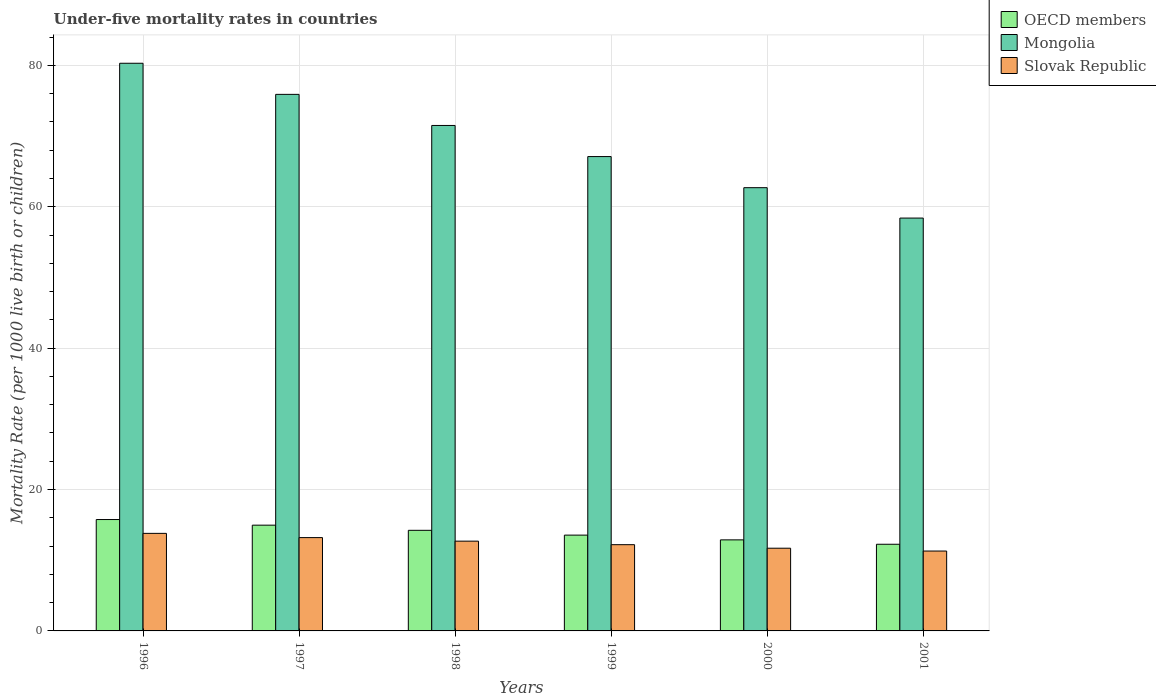How many different coloured bars are there?
Make the answer very short. 3. How many groups of bars are there?
Ensure brevity in your answer.  6. Are the number of bars on each tick of the X-axis equal?
Ensure brevity in your answer.  Yes. What is the label of the 4th group of bars from the left?
Ensure brevity in your answer.  1999. In how many cases, is the number of bars for a given year not equal to the number of legend labels?
Make the answer very short. 0. What is the under-five mortality rate in Mongolia in 1998?
Give a very brief answer. 71.5. Across all years, what is the maximum under-five mortality rate in OECD members?
Keep it short and to the point. 15.76. Across all years, what is the minimum under-five mortality rate in Mongolia?
Your answer should be very brief. 58.4. In which year was the under-five mortality rate in Mongolia maximum?
Your answer should be compact. 1996. What is the total under-five mortality rate in Slovak Republic in the graph?
Offer a terse response. 74.9. What is the difference between the under-five mortality rate in Mongolia in 1996 and that in 1998?
Your answer should be very brief. 8.8. What is the difference between the under-five mortality rate in Mongolia in 1999 and the under-five mortality rate in OECD members in 1996?
Your answer should be compact. 51.34. What is the average under-five mortality rate in Mongolia per year?
Your response must be concise. 69.32. In the year 1997, what is the difference between the under-five mortality rate in OECD members and under-five mortality rate in Mongolia?
Provide a succinct answer. -60.94. What is the ratio of the under-five mortality rate in OECD members in 1997 to that in 1998?
Give a very brief answer. 1.05. Is the under-five mortality rate in OECD members in 1997 less than that in 2000?
Your response must be concise. No. What is the difference between the highest and the second highest under-five mortality rate in Mongolia?
Give a very brief answer. 4.4. What is the difference between the highest and the lowest under-five mortality rate in Slovak Republic?
Offer a very short reply. 2.5. What does the 1st bar from the left in 2001 represents?
Make the answer very short. OECD members. What does the 1st bar from the right in 1998 represents?
Ensure brevity in your answer.  Slovak Republic. How many bars are there?
Offer a terse response. 18. How many years are there in the graph?
Make the answer very short. 6. Does the graph contain any zero values?
Ensure brevity in your answer.  No. How are the legend labels stacked?
Ensure brevity in your answer.  Vertical. What is the title of the graph?
Your answer should be very brief. Under-five mortality rates in countries. What is the label or title of the X-axis?
Offer a very short reply. Years. What is the label or title of the Y-axis?
Make the answer very short. Mortality Rate (per 1000 live birth or children). What is the Mortality Rate (per 1000 live birth or children) of OECD members in 1996?
Your answer should be very brief. 15.76. What is the Mortality Rate (per 1000 live birth or children) in Mongolia in 1996?
Provide a short and direct response. 80.3. What is the Mortality Rate (per 1000 live birth or children) of Slovak Republic in 1996?
Offer a very short reply. 13.8. What is the Mortality Rate (per 1000 live birth or children) in OECD members in 1997?
Offer a very short reply. 14.96. What is the Mortality Rate (per 1000 live birth or children) in Mongolia in 1997?
Offer a very short reply. 75.9. What is the Mortality Rate (per 1000 live birth or children) of OECD members in 1998?
Offer a terse response. 14.23. What is the Mortality Rate (per 1000 live birth or children) in Mongolia in 1998?
Provide a short and direct response. 71.5. What is the Mortality Rate (per 1000 live birth or children) of Slovak Republic in 1998?
Keep it short and to the point. 12.7. What is the Mortality Rate (per 1000 live birth or children) of OECD members in 1999?
Give a very brief answer. 13.55. What is the Mortality Rate (per 1000 live birth or children) in Mongolia in 1999?
Provide a short and direct response. 67.1. What is the Mortality Rate (per 1000 live birth or children) of Slovak Republic in 1999?
Provide a succinct answer. 12.2. What is the Mortality Rate (per 1000 live birth or children) in OECD members in 2000?
Offer a very short reply. 12.88. What is the Mortality Rate (per 1000 live birth or children) of Mongolia in 2000?
Your response must be concise. 62.7. What is the Mortality Rate (per 1000 live birth or children) in OECD members in 2001?
Provide a short and direct response. 12.26. What is the Mortality Rate (per 1000 live birth or children) in Mongolia in 2001?
Provide a short and direct response. 58.4. What is the Mortality Rate (per 1000 live birth or children) of Slovak Republic in 2001?
Offer a terse response. 11.3. Across all years, what is the maximum Mortality Rate (per 1000 live birth or children) in OECD members?
Your response must be concise. 15.76. Across all years, what is the maximum Mortality Rate (per 1000 live birth or children) of Mongolia?
Your answer should be very brief. 80.3. Across all years, what is the maximum Mortality Rate (per 1000 live birth or children) in Slovak Republic?
Your answer should be compact. 13.8. Across all years, what is the minimum Mortality Rate (per 1000 live birth or children) in OECD members?
Provide a succinct answer. 12.26. Across all years, what is the minimum Mortality Rate (per 1000 live birth or children) in Mongolia?
Offer a terse response. 58.4. What is the total Mortality Rate (per 1000 live birth or children) in OECD members in the graph?
Make the answer very short. 83.64. What is the total Mortality Rate (per 1000 live birth or children) of Mongolia in the graph?
Provide a short and direct response. 415.9. What is the total Mortality Rate (per 1000 live birth or children) of Slovak Republic in the graph?
Keep it short and to the point. 74.9. What is the difference between the Mortality Rate (per 1000 live birth or children) in OECD members in 1996 and that in 1997?
Ensure brevity in your answer.  0.8. What is the difference between the Mortality Rate (per 1000 live birth or children) in OECD members in 1996 and that in 1998?
Offer a terse response. 1.53. What is the difference between the Mortality Rate (per 1000 live birth or children) in OECD members in 1996 and that in 1999?
Offer a very short reply. 2.2. What is the difference between the Mortality Rate (per 1000 live birth or children) in OECD members in 1996 and that in 2000?
Give a very brief answer. 2.88. What is the difference between the Mortality Rate (per 1000 live birth or children) of Slovak Republic in 1996 and that in 2000?
Ensure brevity in your answer.  2.1. What is the difference between the Mortality Rate (per 1000 live birth or children) in OECD members in 1996 and that in 2001?
Your answer should be compact. 3.5. What is the difference between the Mortality Rate (per 1000 live birth or children) in Mongolia in 1996 and that in 2001?
Make the answer very short. 21.9. What is the difference between the Mortality Rate (per 1000 live birth or children) of OECD members in 1997 and that in 1998?
Make the answer very short. 0.73. What is the difference between the Mortality Rate (per 1000 live birth or children) in Mongolia in 1997 and that in 1998?
Give a very brief answer. 4.4. What is the difference between the Mortality Rate (per 1000 live birth or children) in Slovak Republic in 1997 and that in 1998?
Offer a very short reply. 0.5. What is the difference between the Mortality Rate (per 1000 live birth or children) of OECD members in 1997 and that in 1999?
Give a very brief answer. 1.41. What is the difference between the Mortality Rate (per 1000 live birth or children) in Mongolia in 1997 and that in 1999?
Offer a very short reply. 8.8. What is the difference between the Mortality Rate (per 1000 live birth or children) in OECD members in 1997 and that in 2000?
Make the answer very short. 2.08. What is the difference between the Mortality Rate (per 1000 live birth or children) in OECD members in 1997 and that in 2001?
Keep it short and to the point. 2.7. What is the difference between the Mortality Rate (per 1000 live birth or children) of Mongolia in 1997 and that in 2001?
Offer a terse response. 17.5. What is the difference between the Mortality Rate (per 1000 live birth or children) in Slovak Republic in 1997 and that in 2001?
Your answer should be compact. 1.9. What is the difference between the Mortality Rate (per 1000 live birth or children) in OECD members in 1998 and that in 1999?
Ensure brevity in your answer.  0.68. What is the difference between the Mortality Rate (per 1000 live birth or children) of Slovak Republic in 1998 and that in 1999?
Make the answer very short. 0.5. What is the difference between the Mortality Rate (per 1000 live birth or children) in OECD members in 1998 and that in 2000?
Offer a very short reply. 1.35. What is the difference between the Mortality Rate (per 1000 live birth or children) of OECD members in 1998 and that in 2001?
Provide a short and direct response. 1.97. What is the difference between the Mortality Rate (per 1000 live birth or children) in Mongolia in 1998 and that in 2001?
Provide a short and direct response. 13.1. What is the difference between the Mortality Rate (per 1000 live birth or children) of OECD members in 1999 and that in 2000?
Give a very brief answer. 0.67. What is the difference between the Mortality Rate (per 1000 live birth or children) of Mongolia in 1999 and that in 2000?
Your answer should be compact. 4.4. What is the difference between the Mortality Rate (per 1000 live birth or children) of Slovak Republic in 1999 and that in 2000?
Make the answer very short. 0.5. What is the difference between the Mortality Rate (per 1000 live birth or children) of OECD members in 1999 and that in 2001?
Your answer should be compact. 1.29. What is the difference between the Mortality Rate (per 1000 live birth or children) of Mongolia in 1999 and that in 2001?
Offer a very short reply. 8.7. What is the difference between the Mortality Rate (per 1000 live birth or children) of Slovak Republic in 1999 and that in 2001?
Give a very brief answer. 0.9. What is the difference between the Mortality Rate (per 1000 live birth or children) of OECD members in 2000 and that in 2001?
Offer a terse response. 0.62. What is the difference between the Mortality Rate (per 1000 live birth or children) of Mongolia in 2000 and that in 2001?
Give a very brief answer. 4.3. What is the difference between the Mortality Rate (per 1000 live birth or children) of Slovak Republic in 2000 and that in 2001?
Provide a short and direct response. 0.4. What is the difference between the Mortality Rate (per 1000 live birth or children) in OECD members in 1996 and the Mortality Rate (per 1000 live birth or children) in Mongolia in 1997?
Your answer should be very brief. -60.14. What is the difference between the Mortality Rate (per 1000 live birth or children) of OECD members in 1996 and the Mortality Rate (per 1000 live birth or children) of Slovak Republic in 1997?
Give a very brief answer. 2.56. What is the difference between the Mortality Rate (per 1000 live birth or children) of Mongolia in 1996 and the Mortality Rate (per 1000 live birth or children) of Slovak Republic in 1997?
Make the answer very short. 67.1. What is the difference between the Mortality Rate (per 1000 live birth or children) in OECD members in 1996 and the Mortality Rate (per 1000 live birth or children) in Mongolia in 1998?
Make the answer very short. -55.74. What is the difference between the Mortality Rate (per 1000 live birth or children) of OECD members in 1996 and the Mortality Rate (per 1000 live birth or children) of Slovak Republic in 1998?
Your answer should be very brief. 3.06. What is the difference between the Mortality Rate (per 1000 live birth or children) of Mongolia in 1996 and the Mortality Rate (per 1000 live birth or children) of Slovak Republic in 1998?
Provide a succinct answer. 67.6. What is the difference between the Mortality Rate (per 1000 live birth or children) in OECD members in 1996 and the Mortality Rate (per 1000 live birth or children) in Mongolia in 1999?
Make the answer very short. -51.34. What is the difference between the Mortality Rate (per 1000 live birth or children) in OECD members in 1996 and the Mortality Rate (per 1000 live birth or children) in Slovak Republic in 1999?
Offer a very short reply. 3.56. What is the difference between the Mortality Rate (per 1000 live birth or children) in Mongolia in 1996 and the Mortality Rate (per 1000 live birth or children) in Slovak Republic in 1999?
Your answer should be compact. 68.1. What is the difference between the Mortality Rate (per 1000 live birth or children) of OECD members in 1996 and the Mortality Rate (per 1000 live birth or children) of Mongolia in 2000?
Your answer should be compact. -46.94. What is the difference between the Mortality Rate (per 1000 live birth or children) of OECD members in 1996 and the Mortality Rate (per 1000 live birth or children) of Slovak Republic in 2000?
Your response must be concise. 4.06. What is the difference between the Mortality Rate (per 1000 live birth or children) of Mongolia in 1996 and the Mortality Rate (per 1000 live birth or children) of Slovak Republic in 2000?
Your answer should be very brief. 68.6. What is the difference between the Mortality Rate (per 1000 live birth or children) in OECD members in 1996 and the Mortality Rate (per 1000 live birth or children) in Mongolia in 2001?
Make the answer very short. -42.64. What is the difference between the Mortality Rate (per 1000 live birth or children) in OECD members in 1996 and the Mortality Rate (per 1000 live birth or children) in Slovak Republic in 2001?
Your answer should be very brief. 4.46. What is the difference between the Mortality Rate (per 1000 live birth or children) of OECD members in 1997 and the Mortality Rate (per 1000 live birth or children) of Mongolia in 1998?
Make the answer very short. -56.54. What is the difference between the Mortality Rate (per 1000 live birth or children) of OECD members in 1997 and the Mortality Rate (per 1000 live birth or children) of Slovak Republic in 1998?
Keep it short and to the point. 2.26. What is the difference between the Mortality Rate (per 1000 live birth or children) in Mongolia in 1997 and the Mortality Rate (per 1000 live birth or children) in Slovak Republic in 1998?
Offer a terse response. 63.2. What is the difference between the Mortality Rate (per 1000 live birth or children) of OECD members in 1997 and the Mortality Rate (per 1000 live birth or children) of Mongolia in 1999?
Provide a short and direct response. -52.14. What is the difference between the Mortality Rate (per 1000 live birth or children) in OECD members in 1997 and the Mortality Rate (per 1000 live birth or children) in Slovak Republic in 1999?
Ensure brevity in your answer.  2.76. What is the difference between the Mortality Rate (per 1000 live birth or children) in Mongolia in 1997 and the Mortality Rate (per 1000 live birth or children) in Slovak Republic in 1999?
Make the answer very short. 63.7. What is the difference between the Mortality Rate (per 1000 live birth or children) of OECD members in 1997 and the Mortality Rate (per 1000 live birth or children) of Mongolia in 2000?
Make the answer very short. -47.74. What is the difference between the Mortality Rate (per 1000 live birth or children) of OECD members in 1997 and the Mortality Rate (per 1000 live birth or children) of Slovak Republic in 2000?
Your response must be concise. 3.26. What is the difference between the Mortality Rate (per 1000 live birth or children) of Mongolia in 1997 and the Mortality Rate (per 1000 live birth or children) of Slovak Republic in 2000?
Your response must be concise. 64.2. What is the difference between the Mortality Rate (per 1000 live birth or children) of OECD members in 1997 and the Mortality Rate (per 1000 live birth or children) of Mongolia in 2001?
Provide a succinct answer. -43.44. What is the difference between the Mortality Rate (per 1000 live birth or children) in OECD members in 1997 and the Mortality Rate (per 1000 live birth or children) in Slovak Republic in 2001?
Give a very brief answer. 3.66. What is the difference between the Mortality Rate (per 1000 live birth or children) of Mongolia in 1997 and the Mortality Rate (per 1000 live birth or children) of Slovak Republic in 2001?
Your answer should be very brief. 64.6. What is the difference between the Mortality Rate (per 1000 live birth or children) in OECD members in 1998 and the Mortality Rate (per 1000 live birth or children) in Mongolia in 1999?
Make the answer very short. -52.87. What is the difference between the Mortality Rate (per 1000 live birth or children) in OECD members in 1998 and the Mortality Rate (per 1000 live birth or children) in Slovak Republic in 1999?
Ensure brevity in your answer.  2.03. What is the difference between the Mortality Rate (per 1000 live birth or children) in Mongolia in 1998 and the Mortality Rate (per 1000 live birth or children) in Slovak Republic in 1999?
Provide a short and direct response. 59.3. What is the difference between the Mortality Rate (per 1000 live birth or children) in OECD members in 1998 and the Mortality Rate (per 1000 live birth or children) in Mongolia in 2000?
Offer a terse response. -48.47. What is the difference between the Mortality Rate (per 1000 live birth or children) in OECD members in 1998 and the Mortality Rate (per 1000 live birth or children) in Slovak Republic in 2000?
Make the answer very short. 2.53. What is the difference between the Mortality Rate (per 1000 live birth or children) of Mongolia in 1998 and the Mortality Rate (per 1000 live birth or children) of Slovak Republic in 2000?
Your answer should be very brief. 59.8. What is the difference between the Mortality Rate (per 1000 live birth or children) of OECD members in 1998 and the Mortality Rate (per 1000 live birth or children) of Mongolia in 2001?
Ensure brevity in your answer.  -44.17. What is the difference between the Mortality Rate (per 1000 live birth or children) of OECD members in 1998 and the Mortality Rate (per 1000 live birth or children) of Slovak Republic in 2001?
Offer a very short reply. 2.93. What is the difference between the Mortality Rate (per 1000 live birth or children) in Mongolia in 1998 and the Mortality Rate (per 1000 live birth or children) in Slovak Republic in 2001?
Give a very brief answer. 60.2. What is the difference between the Mortality Rate (per 1000 live birth or children) of OECD members in 1999 and the Mortality Rate (per 1000 live birth or children) of Mongolia in 2000?
Provide a short and direct response. -49.15. What is the difference between the Mortality Rate (per 1000 live birth or children) of OECD members in 1999 and the Mortality Rate (per 1000 live birth or children) of Slovak Republic in 2000?
Ensure brevity in your answer.  1.85. What is the difference between the Mortality Rate (per 1000 live birth or children) in Mongolia in 1999 and the Mortality Rate (per 1000 live birth or children) in Slovak Republic in 2000?
Keep it short and to the point. 55.4. What is the difference between the Mortality Rate (per 1000 live birth or children) in OECD members in 1999 and the Mortality Rate (per 1000 live birth or children) in Mongolia in 2001?
Your answer should be compact. -44.85. What is the difference between the Mortality Rate (per 1000 live birth or children) of OECD members in 1999 and the Mortality Rate (per 1000 live birth or children) of Slovak Republic in 2001?
Your response must be concise. 2.25. What is the difference between the Mortality Rate (per 1000 live birth or children) in Mongolia in 1999 and the Mortality Rate (per 1000 live birth or children) in Slovak Republic in 2001?
Give a very brief answer. 55.8. What is the difference between the Mortality Rate (per 1000 live birth or children) of OECD members in 2000 and the Mortality Rate (per 1000 live birth or children) of Mongolia in 2001?
Give a very brief answer. -45.52. What is the difference between the Mortality Rate (per 1000 live birth or children) in OECD members in 2000 and the Mortality Rate (per 1000 live birth or children) in Slovak Republic in 2001?
Offer a very short reply. 1.58. What is the difference between the Mortality Rate (per 1000 live birth or children) in Mongolia in 2000 and the Mortality Rate (per 1000 live birth or children) in Slovak Republic in 2001?
Your answer should be compact. 51.4. What is the average Mortality Rate (per 1000 live birth or children) in OECD members per year?
Keep it short and to the point. 13.94. What is the average Mortality Rate (per 1000 live birth or children) in Mongolia per year?
Offer a very short reply. 69.32. What is the average Mortality Rate (per 1000 live birth or children) of Slovak Republic per year?
Ensure brevity in your answer.  12.48. In the year 1996, what is the difference between the Mortality Rate (per 1000 live birth or children) of OECD members and Mortality Rate (per 1000 live birth or children) of Mongolia?
Your response must be concise. -64.54. In the year 1996, what is the difference between the Mortality Rate (per 1000 live birth or children) in OECD members and Mortality Rate (per 1000 live birth or children) in Slovak Republic?
Offer a terse response. 1.96. In the year 1996, what is the difference between the Mortality Rate (per 1000 live birth or children) in Mongolia and Mortality Rate (per 1000 live birth or children) in Slovak Republic?
Your answer should be very brief. 66.5. In the year 1997, what is the difference between the Mortality Rate (per 1000 live birth or children) of OECD members and Mortality Rate (per 1000 live birth or children) of Mongolia?
Your answer should be very brief. -60.94. In the year 1997, what is the difference between the Mortality Rate (per 1000 live birth or children) in OECD members and Mortality Rate (per 1000 live birth or children) in Slovak Republic?
Ensure brevity in your answer.  1.76. In the year 1997, what is the difference between the Mortality Rate (per 1000 live birth or children) of Mongolia and Mortality Rate (per 1000 live birth or children) of Slovak Republic?
Keep it short and to the point. 62.7. In the year 1998, what is the difference between the Mortality Rate (per 1000 live birth or children) of OECD members and Mortality Rate (per 1000 live birth or children) of Mongolia?
Offer a terse response. -57.27. In the year 1998, what is the difference between the Mortality Rate (per 1000 live birth or children) of OECD members and Mortality Rate (per 1000 live birth or children) of Slovak Republic?
Ensure brevity in your answer.  1.53. In the year 1998, what is the difference between the Mortality Rate (per 1000 live birth or children) in Mongolia and Mortality Rate (per 1000 live birth or children) in Slovak Republic?
Keep it short and to the point. 58.8. In the year 1999, what is the difference between the Mortality Rate (per 1000 live birth or children) of OECD members and Mortality Rate (per 1000 live birth or children) of Mongolia?
Your answer should be compact. -53.55. In the year 1999, what is the difference between the Mortality Rate (per 1000 live birth or children) of OECD members and Mortality Rate (per 1000 live birth or children) of Slovak Republic?
Give a very brief answer. 1.35. In the year 1999, what is the difference between the Mortality Rate (per 1000 live birth or children) of Mongolia and Mortality Rate (per 1000 live birth or children) of Slovak Republic?
Your answer should be compact. 54.9. In the year 2000, what is the difference between the Mortality Rate (per 1000 live birth or children) of OECD members and Mortality Rate (per 1000 live birth or children) of Mongolia?
Offer a very short reply. -49.82. In the year 2000, what is the difference between the Mortality Rate (per 1000 live birth or children) of OECD members and Mortality Rate (per 1000 live birth or children) of Slovak Republic?
Give a very brief answer. 1.18. In the year 2000, what is the difference between the Mortality Rate (per 1000 live birth or children) in Mongolia and Mortality Rate (per 1000 live birth or children) in Slovak Republic?
Keep it short and to the point. 51. In the year 2001, what is the difference between the Mortality Rate (per 1000 live birth or children) in OECD members and Mortality Rate (per 1000 live birth or children) in Mongolia?
Your answer should be very brief. -46.14. In the year 2001, what is the difference between the Mortality Rate (per 1000 live birth or children) of OECD members and Mortality Rate (per 1000 live birth or children) of Slovak Republic?
Ensure brevity in your answer.  0.96. In the year 2001, what is the difference between the Mortality Rate (per 1000 live birth or children) in Mongolia and Mortality Rate (per 1000 live birth or children) in Slovak Republic?
Your response must be concise. 47.1. What is the ratio of the Mortality Rate (per 1000 live birth or children) of OECD members in 1996 to that in 1997?
Offer a very short reply. 1.05. What is the ratio of the Mortality Rate (per 1000 live birth or children) of Mongolia in 1996 to that in 1997?
Your response must be concise. 1.06. What is the ratio of the Mortality Rate (per 1000 live birth or children) of Slovak Republic in 1996 to that in 1997?
Offer a very short reply. 1.05. What is the ratio of the Mortality Rate (per 1000 live birth or children) in OECD members in 1996 to that in 1998?
Your answer should be compact. 1.11. What is the ratio of the Mortality Rate (per 1000 live birth or children) in Mongolia in 1996 to that in 1998?
Offer a very short reply. 1.12. What is the ratio of the Mortality Rate (per 1000 live birth or children) of Slovak Republic in 1996 to that in 1998?
Offer a terse response. 1.09. What is the ratio of the Mortality Rate (per 1000 live birth or children) in OECD members in 1996 to that in 1999?
Provide a short and direct response. 1.16. What is the ratio of the Mortality Rate (per 1000 live birth or children) in Mongolia in 1996 to that in 1999?
Provide a short and direct response. 1.2. What is the ratio of the Mortality Rate (per 1000 live birth or children) of Slovak Republic in 1996 to that in 1999?
Your answer should be compact. 1.13. What is the ratio of the Mortality Rate (per 1000 live birth or children) of OECD members in 1996 to that in 2000?
Ensure brevity in your answer.  1.22. What is the ratio of the Mortality Rate (per 1000 live birth or children) in Mongolia in 1996 to that in 2000?
Your answer should be very brief. 1.28. What is the ratio of the Mortality Rate (per 1000 live birth or children) of Slovak Republic in 1996 to that in 2000?
Make the answer very short. 1.18. What is the ratio of the Mortality Rate (per 1000 live birth or children) of OECD members in 1996 to that in 2001?
Your answer should be very brief. 1.29. What is the ratio of the Mortality Rate (per 1000 live birth or children) in Mongolia in 1996 to that in 2001?
Ensure brevity in your answer.  1.38. What is the ratio of the Mortality Rate (per 1000 live birth or children) of Slovak Republic in 1996 to that in 2001?
Offer a terse response. 1.22. What is the ratio of the Mortality Rate (per 1000 live birth or children) of OECD members in 1997 to that in 1998?
Make the answer very short. 1.05. What is the ratio of the Mortality Rate (per 1000 live birth or children) of Mongolia in 1997 to that in 1998?
Make the answer very short. 1.06. What is the ratio of the Mortality Rate (per 1000 live birth or children) in Slovak Republic in 1997 to that in 1998?
Ensure brevity in your answer.  1.04. What is the ratio of the Mortality Rate (per 1000 live birth or children) in OECD members in 1997 to that in 1999?
Offer a very short reply. 1.1. What is the ratio of the Mortality Rate (per 1000 live birth or children) in Mongolia in 1997 to that in 1999?
Provide a succinct answer. 1.13. What is the ratio of the Mortality Rate (per 1000 live birth or children) in Slovak Republic in 1997 to that in 1999?
Your answer should be compact. 1.08. What is the ratio of the Mortality Rate (per 1000 live birth or children) of OECD members in 1997 to that in 2000?
Offer a very short reply. 1.16. What is the ratio of the Mortality Rate (per 1000 live birth or children) in Mongolia in 1997 to that in 2000?
Provide a succinct answer. 1.21. What is the ratio of the Mortality Rate (per 1000 live birth or children) of Slovak Republic in 1997 to that in 2000?
Offer a very short reply. 1.13. What is the ratio of the Mortality Rate (per 1000 live birth or children) in OECD members in 1997 to that in 2001?
Provide a succinct answer. 1.22. What is the ratio of the Mortality Rate (per 1000 live birth or children) in Mongolia in 1997 to that in 2001?
Provide a succinct answer. 1.3. What is the ratio of the Mortality Rate (per 1000 live birth or children) in Slovak Republic in 1997 to that in 2001?
Keep it short and to the point. 1.17. What is the ratio of the Mortality Rate (per 1000 live birth or children) in OECD members in 1998 to that in 1999?
Offer a very short reply. 1.05. What is the ratio of the Mortality Rate (per 1000 live birth or children) in Mongolia in 1998 to that in 1999?
Keep it short and to the point. 1.07. What is the ratio of the Mortality Rate (per 1000 live birth or children) of Slovak Republic in 1998 to that in 1999?
Ensure brevity in your answer.  1.04. What is the ratio of the Mortality Rate (per 1000 live birth or children) in OECD members in 1998 to that in 2000?
Your response must be concise. 1.1. What is the ratio of the Mortality Rate (per 1000 live birth or children) in Mongolia in 1998 to that in 2000?
Ensure brevity in your answer.  1.14. What is the ratio of the Mortality Rate (per 1000 live birth or children) in Slovak Republic in 1998 to that in 2000?
Provide a succinct answer. 1.09. What is the ratio of the Mortality Rate (per 1000 live birth or children) in OECD members in 1998 to that in 2001?
Give a very brief answer. 1.16. What is the ratio of the Mortality Rate (per 1000 live birth or children) in Mongolia in 1998 to that in 2001?
Ensure brevity in your answer.  1.22. What is the ratio of the Mortality Rate (per 1000 live birth or children) of Slovak Republic in 1998 to that in 2001?
Your answer should be compact. 1.12. What is the ratio of the Mortality Rate (per 1000 live birth or children) of OECD members in 1999 to that in 2000?
Your answer should be compact. 1.05. What is the ratio of the Mortality Rate (per 1000 live birth or children) in Mongolia in 1999 to that in 2000?
Offer a terse response. 1.07. What is the ratio of the Mortality Rate (per 1000 live birth or children) in Slovak Republic in 1999 to that in 2000?
Ensure brevity in your answer.  1.04. What is the ratio of the Mortality Rate (per 1000 live birth or children) of OECD members in 1999 to that in 2001?
Your answer should be compact. 1.11. What is the ratio of the Mortality Rate (per 1000 live birth or children) in Mongolia in 1999 to that in 2001?
Make the answer very short. 1.15. What is the ratio of the Mortality Rate (per 1000 live birth or children) of Slovak Republic in 1999 to that in 2001?
Offer a terse response. 1.08. What is the ratio of the Mortality Rate (per 1000 live birth or children) in OECD members in 2000 to that in 2001?
Offer a terse response. 1.05. What is the ratio of the Mortality Rate (per 1000 live birth or children) in Mongolia in 2000 to that in 2001?
Give a very brief answer. 1.07. What is the ratio of the Mortality Rate (per 1000 live birth or children) in Slovak Republic in 2000 to that in 2001?
Provide a succinct answer. 1.04. What is the difference between the highest and the second highest Mortality Rate (per 1000 live birth or children) in OECD members?
Provide a short and direct response. 0.8. What is the difference between the highest and the lowest Mortality Rate (per 1000 live birth or children) in OECD members?
Ensure brevity in your answer.  3.5. What is the difference between the highest and the lowest Mortality Rate (per 1000 live birth or children) of Mongolia?
Your answer should be very brief. 21.9. What is the difference between the highest and the lowest Mortality Rate (per 1000 live birth or children) of Slovak Republic?
Keep it short and to the point. 2.5. 